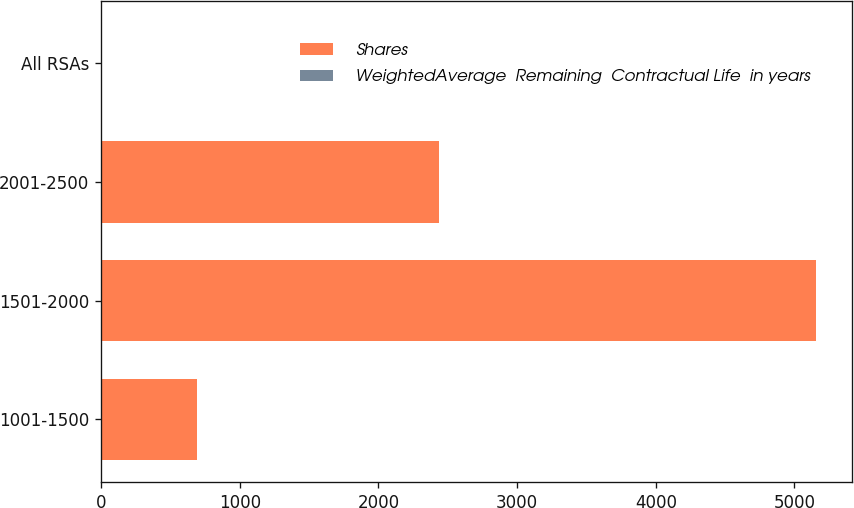Convert chart. <chart><loc_0><loc_0><loc_500><loc_500><stacked_bar_chart><ecel><fcel>1001-1500<fcel>1501-2000<fcel>2001-2500<fcel>All RSAs<nl><fcel>Shares<fcel>690<fcel>5153<fcel>2438<fcel>1.6<nl><fcel>WeightedAverage  Remaining  Contractual Life  in years<fcel>0.3<fcel>1.6<fcel>1.4<fcel>1.4<nl></chart> 